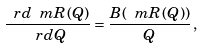<formula> <loc_0><loc_0><loc_500><loc_500>\frac { \ r d { \ m R } ( Q ) } { \ r d Q } = \frac { B ( { \ m R } ( Q ) ) } { Q } \, ,</formula> 